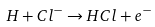<formula> <loc_0><loc_0><loc_500><loc_500>H + C l ^ { - } \rightarrow H C l + e ^ { - }</formula> 